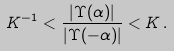Convert formula to latex. <formula><loc_0><loc_0><loc_500><loc_500>K ^ { - 1 } < \frac { | \Upsilon ( \alpha ) | } { | \Upsilon ( - \alpha ) | } < K \, .</formula> 